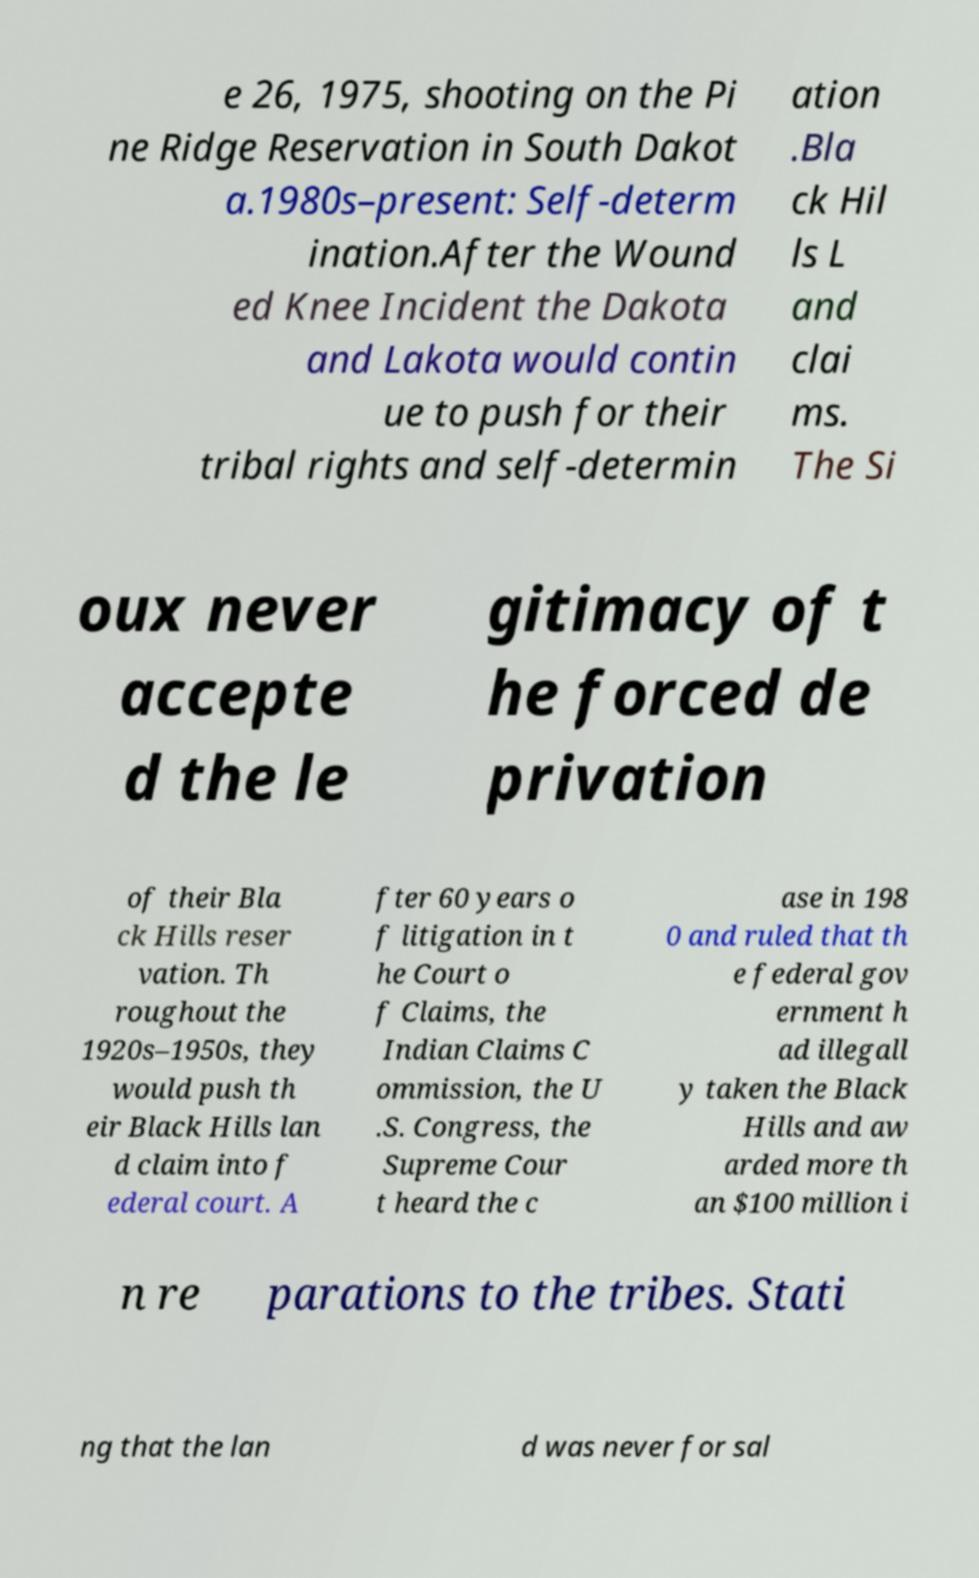I need the written content from this picture converted into text. Can you do that? e 26, 1975, shooting on the Pi ne Ridge Reservation in South Dakot a.1980s–present: Self-determ ination.After the Wound ed Knee Incident the Dakota and Lakota would contin ue to push for their tribal rights and self-determin ation .Bla ck Hil ls L and clai ms. The Si oux never accepte d the le gitimacy of t he forced de privation of their Bla ck Hills reser vation. Th roughout the 1920s–1950s, they would push th eir Black Hills lan d claim into f ederal court. A fter 60 years o f litigation in t he Court o f Claims, the Indian Claims C ommission, the U .S. Congress, the Supreme Cour t heard the c ase in 198 0 and ruled that th e federal gov ernment h ad illegall y taken the Black Hills and aw arded more th an $100 million i n re parations to the tribes. Stati ng that the lan d was never for sal 